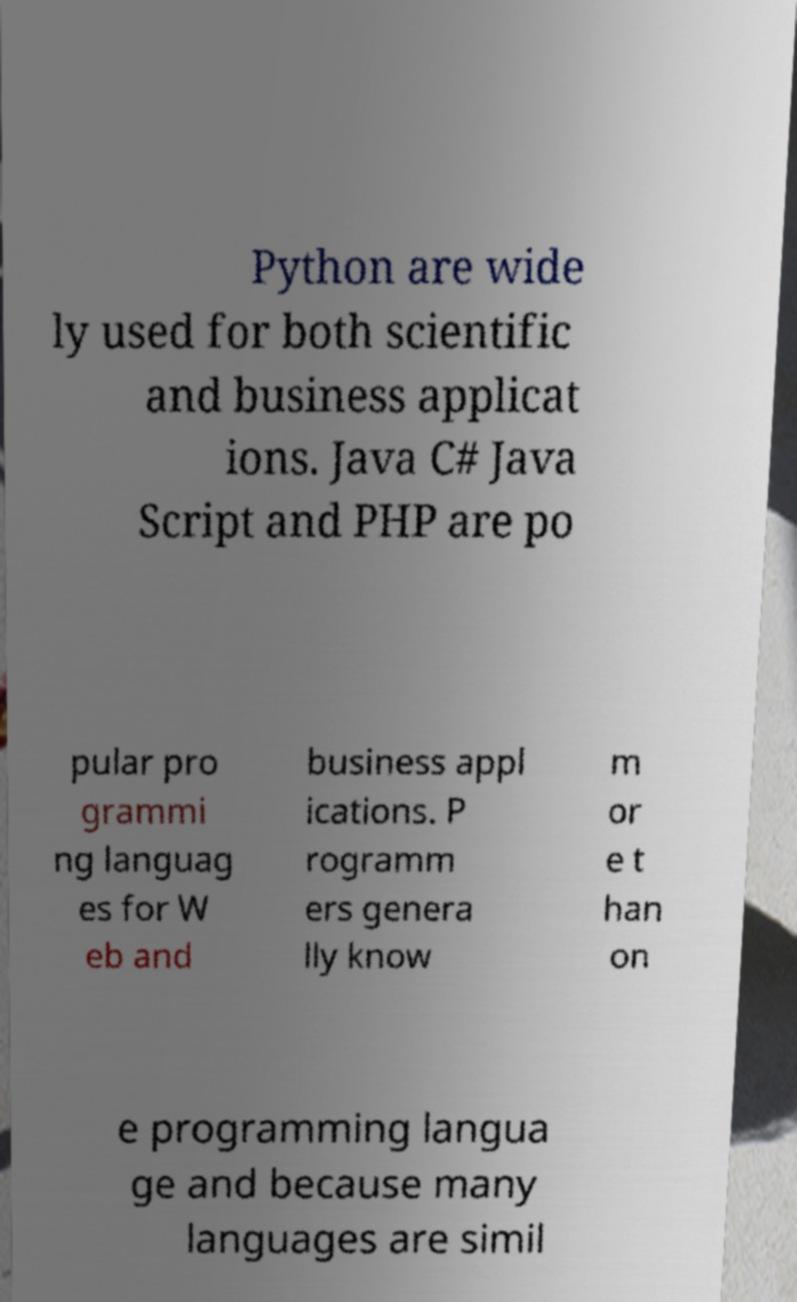I need the written content from this picture converted into text. Can you do that? Python are wide ly used for both scientific and business applicat ions. Java C# Java Script and PHP are po pular pro grammi ng languag es for W eb and business appl ications. P rogramm ers genera lly know m or e t han on e programming langua ge and because many languages are simil 